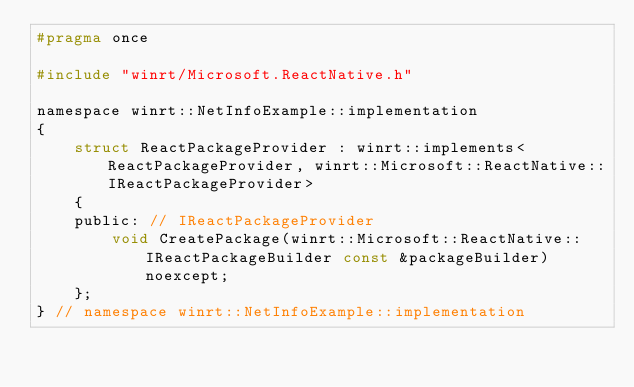Convert code to text. <code><loc_0><loc_0><loc_500><loc_500><_C_>#pragma once

#include "winrt/Microsoft.ReactNative.h"

namespace winrt::NetInfoExample::implementation
{
    struct ReactPackageProvider : winrt::implements<ReactPackageProvider, winrt::Microsoft::ReactNative::IReactPackageProvider>
    {
    public: // IReactPackageProvider
        void CreatePackage(winrt::Microsoft::ReactNative::IReactPackageBuilder const &packageBuilder) noexcept;
    };
} // namespace winrt::NetInfoExample::implementation

</code> 